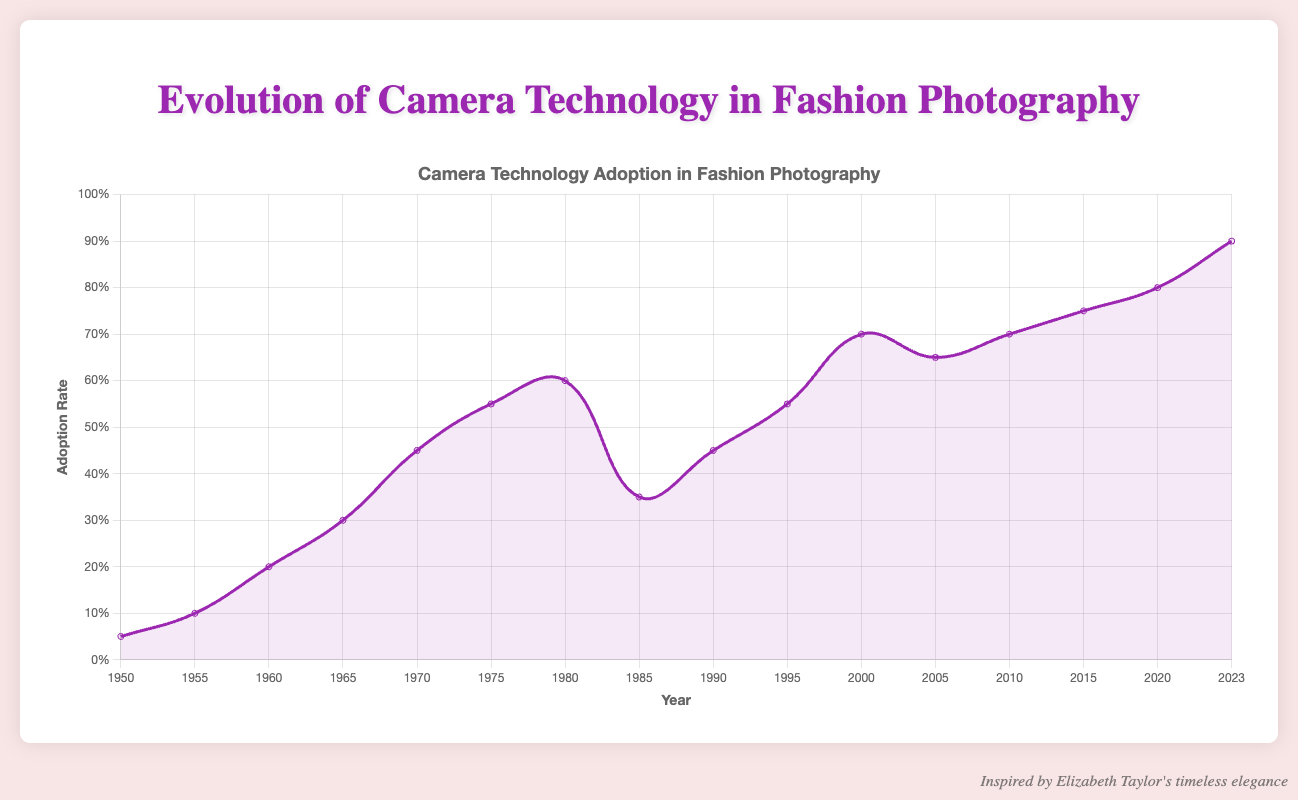What year did the adoption rate first reach 0.70? Look at the plot and find the year corresponding to the adoption rate of 0.70 by following the y-axis value.
Answer: 2000 How much did the adoption rate increase between 1975 and 1980? Identify the adoption rates at 1975 and 1980 from the y-axis and calculate the difference: 0.60 - 0.55 = 0.05
Answer: 0.05 Which camera technology had an adoption rate of 0.35 in 1985? Find the point corresponding to the adoption rate of 0.35 on the y-axis and then trace it to the x-axis to see the year 1985.
Answer: Digital Camera (Early CCD) Was the adoption rate higher in 1990 or 2020? Compare the adoption rates at years 1990 and 2020 from the y-axis values and see which is higher.
Answer: 2020 During which period did the adoption rate decrease? Look for the portion of the line that trends downwards, which is between 1980 and 1985.
Answer: 1980-1985 What was the adoption rate difference between 1965 and 1995? Find the adoption rates at 1965 (0.30) and 1995 (0.55) from the y-axis and subtract the former from the latter: 0.55 - 0.30 = 0.25
Answer: 0.25 In what year was "Introduction of professional digital SLRs" a major technological breakthrough? Find the label "Introduction of professional digital SLRs" and note the corresponding year on the x-axis, which is 1995.
Answer: 1995 What is the average adoption rate from 2015 to 2023? Find the adoption rates for 2015 (0.75), 2020 (0.80), and 2023 (0.90). Calculate the average: (0.75 + 0.80 + 0.90) / 3 = 0.8167 (rounded to 0.82)
Answer: 0.82 Which technological breakthrough occurred in 2010? Align the technological breakthrough labels with the year 2010 on the x-axis, which is "Improved autofocus in mirrorless systems".
Answer: Improved autofocus in mirrorless systems By how much did the adoption rate grow from the introduction of large format cameras to the use of computational photography in smartphones? Determine the adoption rates at 1950 (0.05) and 2023 (0.90). Calculate the increase: 0.90 - 0.05 = 0.85
Answer: 0.85 